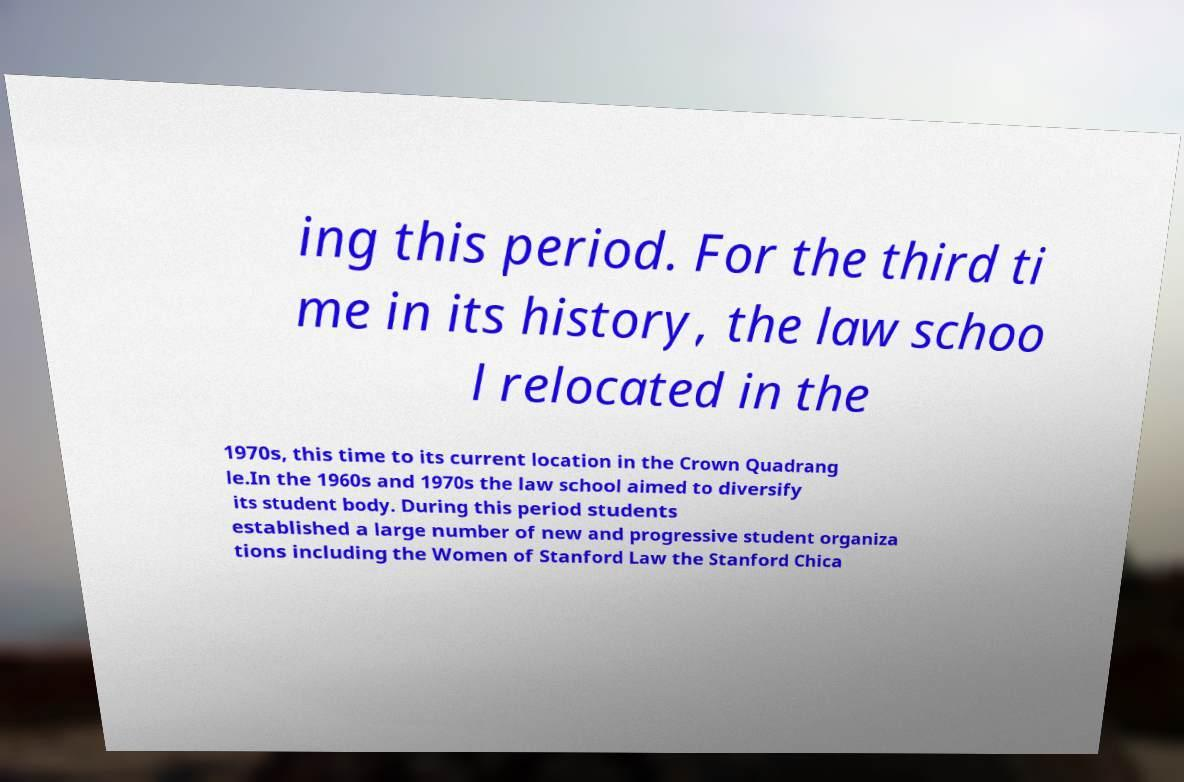Can you accurately transcribe the text from the provided image for me? ing this period. For the third ti me in its history, the law schoo l relocated in the 1970s, this time to its current location in the Crown Quadrang le.In the 1960s and 1970s the law school aimed to diversify its student body. During this period students established a large number of new and progressive student organiza tions including the Women of Stanford Law the Stanford Chica 